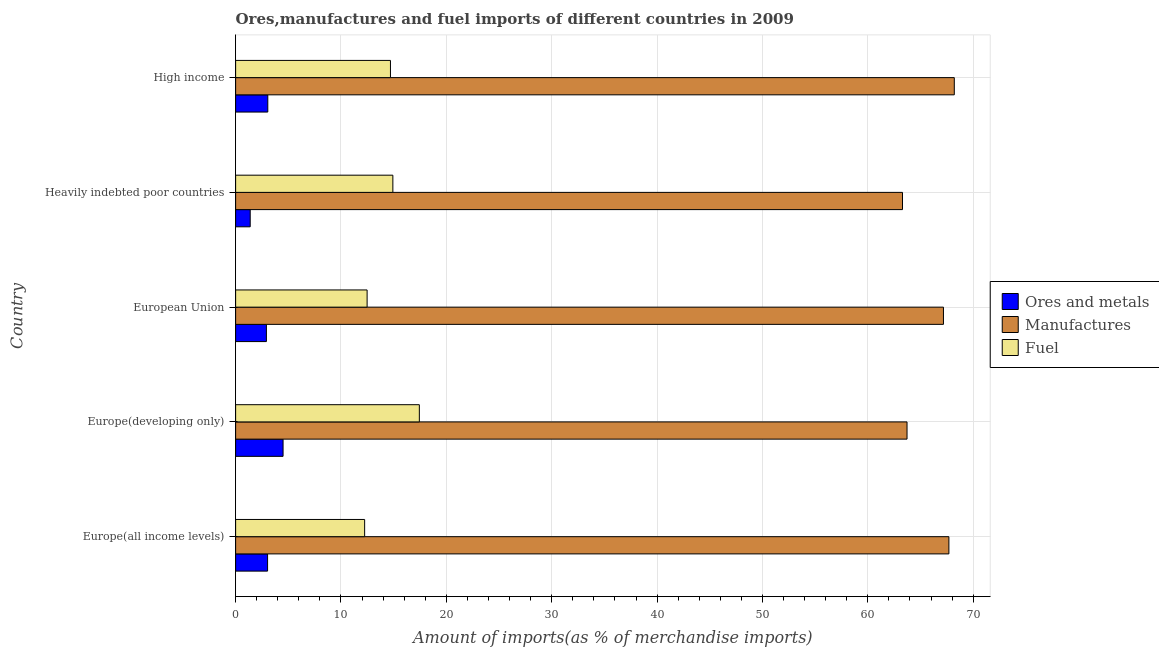How many groups of bars are there?
Your answer should be very brief. 5. Are the number of bars per tick equal to the number of legend labels?
Provide a short and direct response. Yes. How many bars are there on the 4th tick from the bottom?
Offer a very short reply. 3. What is the label of the 4th group of bars from the top?
Provide a short and direct response. Europe(developing only). What is the percentage of fuel imports in Europe(all income levels)?
Make the answer very short. 12.24. Across all countries, what is the maximum percentage of ores and metals imports?
Your answer should be compact. 4.5. Across all countries, what is the minimum percentage of manufactures imports?
Make the answer very short. 63.29. In which country was the percentage of ores and metals imports maximum?
Offer a terse response. Europe(developing only). In which country was the percentage of ores and metals imports minimum?
Your answer should be very brief. Heavily indebted poor countries. What is the total percentage of manufactures imports in the graph?
Make the answer very short. 330.09. What is the difference between the percentage of fuel imports in European Union and that in High income?
Your response must be concise. -2.22. What is the difference between the percentage of ores and metals imports in High income and the percentage of manufactures imports in Europe(all income levels)?
Make the answer very short. -64.64. What is the average percentage of ores and metals imports per country?
Keep it short and to the point. 2.98. What is the difference between the percentage of fuel imports and percentage of manufactures imports in Heavily indebted poor countries?
Provide a succinct answer. -48.37. In how many countries, is the percentage of ores and metals imports greater than 42 %?
Your response must be concise. 0. Is the percentage of fuel imports in Europe(all income levels) less than that in Heavily indebted poor countries?
Your answer should be compact. Yes. Is the difference between the percentage of manufactures imports in Heavily indebted poor countries and High income greater than the difference between the percentage of fuel imports in Heavily indebted poor countries and High income?
Make the answer very short. No. What is the difference between the highest and the second highest percentage of manufactures imports?
Your answer should be very brief. 0.51. What is the difference between the highest and the lowest percentage of ores and metals imports?
Offer a very short reply. 3.12. In how many countries, is the percentage of ores and metals imports greater than the average percentage of ores and metals imports taken over all countries?
Make the answer very short. 3. What does the 3rd bar from the top in Heavily indebted poor countries represents?
Make the answer very short. Ores and metals. What does the 1st bar from the bottom in Europe(all income levels) represents?
Your response must be concise. Ores and metals. How many bars are there?
Your response must be concise. 15. Are all the bars in the graph horizontal?
Offer a terse response. Yes. What is the difference between two consecutive major ticks on the X-axis?
Give a very brief answer. 10. Does the graph contain grids?
Ensure brevity in your answer.  Yes. How many legend labels are there?
Make the answer very short. 3. How are the legend labels stacked?
Offer a very short reply. Vertical. What is the title of the graph?
Your answer should be compact. Ores,manufactures and fuel imports of different countries in 2009. Does "Textiles and clothing" appear as one of the legend labels in the graph?
Your answer should be very brief. No. What is the label or title of the X-axis?
Offer a very short reply. Amount of imports(as % of merchandise imports). What is the label or title of the Y-axis?
Make the answer very short. Country. What is the Amount of imports(as % of merchandise imports) of Ores and metals in Europe(all income levels)?
Your answer should be very brief. 3.03. What is the Amount of imports(as % of merchandise imports) of Manufactures in Europe(all income levels)?
Offer a very short reply. 67.69. What is the Amount of imports(as % of merchandise imports) of Fuel in Europe(all income levels)?
Ensure brevity in your answer.  12.24. What is the Amount of imports(as % of merchandise imports) of Ores and metals in Europe(developing only)?
Offer a very short reply. 4.5. What is the Amount of imports(as % of merchandise imports) of Manufactures in Europe(developing only)?
Offer a terse response. 63.72. What is the Amount of imports(as % of merchandise imports) of Fuel in Europe(developing only)?
Make the answer very short. 17.44. What is the Amount of imports(as % of merchandise imports) in Ores and metals in European Union?
Your answer should be compact. 2.92. What is the Amount of imports(as % of merchandise imports) in Manufactures in European Union?
Ensure brevity in your answer.  67.18. What is the Amount of imports(as % of merchandise imports) in Fuel in European Union?
Give a very brief answer. 12.48. What is the Amount of imports(as % of merchandise imports) of Ores and metals in Heavily indebted poor countries?
Provide a short and direct response. 1.38. What is the Amount of imports(as % of merchandise imports) of Manufactures in Heavily indebted poor countries?
Offer a terse response. 63.29. What is the Amount of imports(as % of merchandise imports) in Fuel in Heavily indebted poor countries?
Provide a short and direct response. 14.92. What is the Amount of imports(as % of merchandise imports) in Ores and metals in High income?
Your answer should be very brief. 3.05. What is the Amount of imports(as % of merchandise imports) of Manufactures in High income?
Ensure brevity in your answer.  68.21. What is the Amount of imports(as % of merchandise imports) of Fuel in High income?
Your answer should be compact. 14.7. Across all countries, what is the maximum Amount of imports(as % of merchandise imports) in Ores and metals?
Your answer should be very brief. 4.5. Across all countries, what is the maximum Amount of imports(as % of merchandise imports) of Manufactures?
Offer a very short reply. 68.21. Across all countries, what is the maximum Amount of imports(as % of merchandise imports) of Fuel?
Offer a very short reply. 17.44. Across all countries, what is the minimum Amount of imports(as % of merchandise imports) in Ores and metals?
Ensure brevity in your answer.  1.38. Across all countries, what is the minimum Amount of imports(as % of merchandise imports) of Manufactures?
Provide a succinct answer. 63.29. Across all countries, what is the minimum Amount of imports(as % of merchandise imports) in Fuel?
Your answer should be very brief. 12.24. What is the total Amount of imports(as % of merchandise imports) of Ores and metals in the graph?
Offer a very short reply. 14.9. What is the total Amount of imports(as % of merchandise imports) in Manufactures in the graph?
Your answer should be compact. 330.09. What is the total Amount of imports(as % of merchandise imports) in Fuel in the graph?
Your response must be concise. 71.78. What is the difference between the Amount of imports(as % of merchandise imports) of Ores and metals in Europe(all income levels) and that in Europe(developing only)?
Keep it short and to the point. -1.47. What is the difference between the Amount of imports(as % of merchandise imports) of Manufactures in Europe(all income levels) and that in Europe(developing only)?
Give a very brief answer. 3.97. What is the difference between the Amount of imports(as % of merchandise imports) of Fuel in Europe(all income levels) and that in Europe(developing only)?
Offer a terse response. -5.19. What is the difference between the Amount of imports(as % of merchandise imports) in Manufactures in Europe(all income levels) and that in European Union?
Keep it short and to the point. 0.52. What is the difference between the Amount of imports(as % of merchandise imports) in Fuel in Europe(all income levels) and that in European Union?
Give a very brief answer. -0.23. What is the difference between the Amount of imports(as % of merchandise imports) in Ores and metals in Europe(all income levels) and that in Heavily indebted poor countries?
Give a very brief answer. 1.65. What is the difference between the Amount of imports(as % of merchandise imports) in Manufactures in Europe(all income levels) and that in Heavily indebted poor countries?
Provide a short and direct response. 4.4. What is the difference between the Amount of imports(as % of merchandise imports) of Fuel in Europe(all income levels) and that in Heavily indebted poor countries?
Offer a very short reply. -2.68. What is the difference between the Amount of imports(as % of merchandise imports) in Ores and metals in Europe(all income levels) and that in High income?
Ensure brevity in your answer.  -0.02. What is the difference between the Amount of imports(as % of merchandise imports) in Manufactures in Europe(all income levels) and that in High income?
Your answer should be very brief. -0.51. What is the difference between the Amount of imports(as % of merchandise imports) in Fuel in Europe(all income levels) and that in High income?
Ensure brevity in your answer.  -2.45. What is the difference between the Amount of imports(as % of merchandise imports) in Ores and metals in Europe(developing only) and that in European Union?
Provide a short and direct response. 1.58. What is the difference between the Amount of imports(as % of merchandise imports) of Manufactures in Europe(developing only) and that in European Union?
Make the answer very short. -3.46. What is the difference between the Amount of imports(as % of merchandise imports) in Fuel in Europe(developing only) and that in European Union?
Make the answer very short. 4.96. What is the difference between the Amount of imports(as % of merchandise imports) of Ores and metals in Europe(developing only) and that in Heavily indebted poor countries?
Your answer should be compact. 3.12. What is the difference between the Amount of imports(as % of merchandise imports) of Manufactures in Europe(developing only) and that in Heavily indebted poor countries?
Provide a succinct answer. 0.43. What is the difference between the Amount of imports(as % of merchandise imports) of Fuel in Europe(developing only) and that in Heavily indebted poor countries?
Keep it short and to the point. 2.51. What is the difference between the Amount of imports(as % of merchandise imports) in Ores and metals in Europe(developing only) and that in High income?
Give a very brief answer. 1.45. What is the difference between the Amount of imports(as % of merchandise imports) in Manufactures in Europe(developing only) and that in High income?
Your answer should be compact. -4.49. What is the difference between the Amount of imports(as % of merchandise imports) in Fuel in Europe(developing only) and that in High income?
Keep it short and to the point. 2.74. What is the difference between the Amount of imports(as % of merchandise imports) in Ores and metals in European Union and that in Heavily indebted poor countries?
Provide a succinct answer. 1.54. What is the difference between the Amount of imports(as % of merchandise imports) of Manufactures in European Union and that in Heavily indebted poor countries?
Make the answer very short. 3.89. What is the difference between the Amount of imports(as % of merchandise imports) in Fuel in European Union and that in Heavily indebted poor countries?
Your answer should be compact. -2.44. What is the difference between the Amount of imports(as % of merchandise imports) of Ores and metals in European Union and that in High income?
Make the answer very short. -0.13. What is the difference between the Amount of imports(as % of merchandise imports) in Manufactures in European Union and that in High income?
Your answer should be very brief. -1.03. What is the difference between the Amount of imports(as % of merchandise imports) in Fuel in European Union and that in High income?
Ensure brevity in your answer.  -2.22. What is the difference between the Amount of imports(as % of merchandise imports) in Ores and metals in Heavily indebted poor countries and that in High income?
Provide a short and direct response. -1.67. What is the difference between the Amount of imports(as % of merchandise imports) of Manufactures in Heavily indebted poor countries and that in High income?
Give a very brief answer. -4.92. What is the difference between the Amount of imports(as % of merchandise imports) of Fuel in Heavily indebted poor countries and that in High income?
Keep it short and to the point. 0.23. What is the difference between the Amount of imports(as % of merchandise imports) of Ores and metals in Europe(all income levels) and the Amount of imports(as % of merchandise imports) of Manufactures in Europe(developing only)?
Your answer should be compact. -60.69. What is the difference between the Amount of imports(as % of merchandise imports) in Ores and metals in Europe(all income levels) and the Amount of imports(as % of merchandise imports) in Fuel in Europe(developing only)?
Your response must be concise. -14.4. What is the difference between the Amount of imports(as % of merchandise imports) of Manufactures in Europe(all income levels) and the Amount of imports(as % of merchandise imports) of Fuel in Europe(developing only)?
Provide a short and direct response. 50.26. What is the difference between the Amount of imports(as % of merchandise imports) of Ores and metals in Europe(all income levels) and the Amount of imports(as % of merchandise imports) of Manufactures in European Union?
Provide a succinct answer. -64.14. What is the difference between the Amount of imports(as % of merchandise imports) of Ores and metals in Europe(all income levels) and the Amount of imports(as % of merchandise imports) of Fuel in European Union?
Offer a terse response. -9.45. What is the difference between the Amount of imports(as % of merchandise imports) of Manufactures in Europe(all income levels) and the Amount of imports(as % of merchandise imports) of Fuel in European Union?
Give a very brief answer. 55.22. What is the difference between the Amount of imports(as % of merchandise imports) in Ores and metals in Europe(all income levels) and the Amount of imports(as % of merchandise imports) in Manufactures in Heavily indebted poor countries?
Your answer should be compact. -60.26. What is the difference between the Amount of imports(as % of merchandise imports) in Ores and metals in Europe(all income levels) and the Amount of imports(as % of merchandise imports) in Fuel in Heavily indebted poor countries?
Give a very brief answer. -11.89. What is the difference between the Amount of imports(as % of merchandise imports) of Manufactures in Europe(all income levels) and the Amount of imports(as % of merchandise imports) of Fuel in Heavily indebted poor countries?
Give a very brief answer. 52.77. What is the difference between the Amount of imports(as % of merchandise imports) in Ores and metals in Europe(all income levels) and the Amount of imports(as % of merchandise imports) in Manufactures in High income?
Offer a very short reply. -65.17. What is the difference between the Amount of imports(as % of merchandise imports) in Ores and metals in Europe(all income levels) and the Amount of imports(as % of merchandise imports) in Fuel in High income?
Provide a short and direct response. -11.66. What is the difference between the Amount of imports(as % of merchandise imports) of Manufactures in Europe(all income levels) and the Amount of imports(as % of merchandise imports) of Fuel in High income?
Your response must be concise. 53. What is the difference between the Amount of imports(as % of merchandise imports) of Ores and metals in Europe(developing only) and the Amount of imports(as % of merchandise imports) of Manufactures in European Union?
Your response must be concise. -62.67. What is the difference between the Amount of imports(as % of merchandise imports) in Ores and metals in Europe(developing only) and the Amount of imports(as % of merchandise imports) in Fuel in European Union?
Keep it short and to the point. -7.98. What is the difference between the Amount of imports(as % of merchandise imports) of Manufactures in Europe(developing only) and the Amount of imports(as % of merchandise imports) of Fuel in European Union?
Make the answer very short. 51.24. What is the difference between the Amount of imports(as % of merchandise imports) of Ores and metals in Europe(developing only) and the Amount of imports(as % of merchandise imports) of Manufactures in Heavily indebted poor countries?
Make the answer very short. -58.79. What is the difference between the Amount of imports(as % of merchandise imports) in Ores and metals in Europe(developing only) and the Amount of imports(as % of merchandise imports) in Fuel in Heavily indebted poor countries?
Give a very brief answer. -10.42. What is the difference between the Amount of imports(as % of merchandise imports) in Manufactures in Europe(developing only) and the Amount of imports(as % of merchandise imports) in Fuel in Heavily indebted poor countries?
Offer a very short reply. 48.8. What is the difference between the Amount of imports(as % of merchandise imports) of Ores and metals in Europe(developing only) and the Amount of imports(as % of merchandise imports) of Manufactures in High income?
Keep it short and to the point. -63.7. What is the difference between the Amount of imports(as % of merchandise imports) of Ores and metals in Europe(developing only) and the Amount of imports(as % of merchandise imports) of Fuel in High income?
Your answer should be very brief. -10.19. What is the difference between the Amount of imports(as % of merchandise imports) of Manufactures in Europe(developing only) and the Amount of imports(as % of merchandise imports) of Fuel in High income?
Keep it short and to the point. 49.03. What is the difference between the Amount of imports(as % of merchandise imports) of Ores and metals in European Union and the Amount of imports(as % of merchandise imports) of Manufactures in Heavily indebted poor countries?
Provide a short and direct response. -60.37. What is the difference between the Amount of imports(as % of merchandise imports) of Ores and metals in European Union and the Amount of imports(as % of merchandise imports) of Fuel in Heavily indebted poor countries?
Give a very brief answer. -12. What is the difference between the Amount of imports(as % of merchandise imports) in Manufactures in European Union and the Amount of imports(as % of merchandise imports) in Fuel in Heavily indebted poor countries?
Provide a succinct answer. 52.25. What is the difference between the Amount of imports(as % of merchandise imports) in Ores and metals in European Union and the Amount of imports(as % of merchandise imports) in Manufactures in High income?
Provide a succinct answer. -65.29. What is the difference between the Amount of imports(as % of merchandise imports) in Ores and metals in European Union and the Amount of imports(as % of merchandise imports) in Fuel in High income?
Make the answer very short. -11.77. What is the difference between the Amount of imports(as % of merchandise imports) in Manufactures in European Union and the Amount of imports(as % of merchandise imports) in Fuel in High income?
Provide a succinct answer. 52.48. What is the difference between the Amount of imports(as % of merchandise imports) in Ores and metals in Heavily indebted poor countries and the Amount of imports(as % of merchandise imports) in Manufactures in High income?
Your response must be concise. -66.82. What is the difference between the Amount of imports(as % of merchandise imports) of Ores and metals in Heavily indebted poor countries and the Amount of imports(as % of merchandise imports) of Fuel in High income?
Offer a terse response. -13.31. What is the difference between the Amount of imports(as % of merchandise imports) in Manufactures in Heavily indebted poor countries and the Amount of imports(as % of merchandise imports) in Fuel in High income?
Your answer should be very brief. 48.6. What is the average Amount of imports(as % of merchandise imports) of Ores and metals per country?
Keep it short and to the point. 2.98. What is the average Amount of imports(as % of merchandise imports) in Manufactures per country?
Provide a short and direct response. 66.02. What is the average Amount of imports(as % of merchandise imports) in Fuel per country?
Make the answer very short. 14.36. What is the difference between the Amount of imports(as % of merchandise imports) of Ores and metals and Amount of imports(as % of merchandise imports) of Manufactures in Europe(all income levels)?
Provide a short and direct response. -64.66. What is the difference between the Amount of imports(as % of merchandise imports) of Ores and metals and Amount of imports(as % of merchandise imports) of Fuel in Europe(all income levels)?
Provide a short and direct response. -9.21. What is the difference between the Amount of imports(as % of merchandise imports) of Manufactures and Amount of imports(as % of merchandise imports) of Fuel in Europe(all income levels)?
Offer a very short reply. 55.45. What is the difference between the Amount of imports(as % of merchandise imports) in Ores and metals and Amount of imports(as % of merchandise imports) in Manufactures in Europe(developing only)?
Keep it short and to the point. -59.22. What is the difference between the Amount of imports(as % of merchandise imports) of Ores and metals and Amount of imports(as % of merchandise imports) of Fuel in Europe(developing only)?
Your answer should be compact. -12.93. What is the difference between the Amount of imports(as % of merchandise imports) of Manufactures and Amount of imports(as % of merchandise imports) of Fuel in Europe(developing only)?
Offer a terse response. 46.29. What is the difference between the Amount of imports(as % of merchandise imports) in Ores and metals and Amount of imports(as % of merchandise imports) in Manufactures in European Union?
Offer a terse response. -64.26. What is the difference between the Amount of imports(as % of merchandise imports) of Ores and metals and Amount of imports(as % of merchandise imports) of Fuel in European Union?
Ensure brevity in your answer.  -9.56. What is the difference between the Amount of imports(as % of merchandise imports) of Manufactures and Amount of imports(as % of merchandise imports) of Fuel in European Union?
Give a very brief answer. 54.7. What is the difference between the Amount of imports(as % of merchandise imports) of Ores and metals and Amount of imports(as % of merchandise imports) of Manufactures in Heavily indebted poor countries?
Make the answer very short. -61.91. What is the difference between the Amount of imports(as % of merchandise imports) in Ores and metals and Amount of imports(as % of merchandise imports) in Fuel in Heavily indebted poor countries?
Give a very brief answer. -13.54. What is the difference between the Amount of imports(as % of merchandise imports) in Manufactures and Amount of imports(as % of merchandise imports) in Fuel in Heavily indebted poor countries?
Make the answer very short. 48.37. What is the difference between the Amount of imports(as % of merchandise imports) in Ores and metals and Amount of imports(as % of merchandise imports) in Manufactures in High income?
Keep it short and to the point. -65.15. What is the difference between the Amount of imports(as % of merchandise imports) in Ores and metals and Amount of imports(as % of merchandise imports) in Fuel in High income?
Offer a terse response. -11.64. What is the difference between the Amount of imports(as % of merchandise imports) in Manufactures and Amount of imports(as % of merchandise imports) in Fuel in High income?
Ensure brevity in your answer.  53.51. What is the ratio of the Amount of imports(as % of merchandise imports) of Ores and metals in Europe(all income levels) to that in Europe(developing only)?
Give a very brief answer. 0.67. What is the ratio of the Amount of imports(as % of merchandise imports) of Manufactures in Europe(all income levels) to that in Europe(developing only)?
Ensure brevity in your answer.  1.06. What is the ratio of the Amount of imports(as % of merchandise imports) of Fuel in Europe(all income levels) to that in Europe(developing only)?
Offer a very short reply. 0.7. What is the ratio of the Amount of imports(as % of merchandise imports) of Ores and metals in Europe(all income levels) to that in European Union?
Your response must be concise. 1.04. What is the ratio of the Amount of imports(as % of merchandise imports) in Manufactures in Europe(all income levels) to that in European Union?
Provide a succinct answer. 1.01. What is the ratio of the Amount of imports(as % of merchandise imports) in Fuel in Europe(all income levels) to that in European Union?
Give a very brief answer. 0.98. What is the ratio of the Amount of imports(as % of merchandise imports) of Ores and metals in Europe(all income levels) to that in Heavily indebted poor countries?
Ensure brevity in your answer.  2.19. What is the ratio of the Amount of imports(as % of merchandise imports) of Manufactures in Europe(all income levels) to that in Heavily indebted poor countries?
Your response must be concise. 1.07. What is the ratio of the Amount of imports(as % of merchandise imports) in Fuel in Europe(all income levels) to that in Heavily indebted poor countries?
Offer a very short reply. 0.82. What is the ratio of the Amount of imports(as % of merchandise imports) in Ores and metals in Europe(all income levels) to that in High income?
Ensure brevity in your answer.  0.99. What is the ratio of the Amount of imports(as % of merchandise imports) in Fuel in Europe(all income levels) to that in High income?
Offer a very short reply. 0.83. What is the ratio of the Amount of imports(as % of merchandise imports) of Ores and metals in Europe(developing only) to that in European Union?
Provide a succinct answer. 1.54. What is the ratio of the Amount of imports(as % of merchandise imports) in Manufactures in Europe(developing only) to that in European Union?
Your answer should be compact. 0.95. What is the ratio of the Amount of imports(as % of merchandise imports) of Fuel in Europe(developing only) to that in European Union?
Give a very brief answer. 1.4. What is the ratio of the Amount of imports(as % of merchandise imports) of Ores and metals in Europe(developing only) to that in Heavily indebted poor countries?
Your answer should be compact. 3.25. What is the ratio of the Amount of imports(as % of merchandise imports) in Manufactures in Europe(developing only) to that in Heavily indebted poor countries?
Your answer should be compact. 1.01. What is the ratio of the Amount of imports(as % of merchandise imports) of Fuel in Europe(developing only) to that in Heavily indebted poor countries?
Keep it short and to the point. 1.17. What is the ratio of the Amount of imports(as % of merchandise imports) of Ores and metals in Europe(developing only) to that in High income?
Make the answer very short. 1.47. What is the ratio of the Amount of imports(as % of merchandise imports) in Manufactures in Europe(developing only) to that in High income?
Offer a terse response. 0.93. What is the ratio of the Amount of imports(as % of merchandise imports) of Fuel in Europe(developing only) to that in High income?
Keep it short and to the point. 1.19. What is the ratio of the Amount of imports(as % of merchandise imports) in Ores and metals in European Union to that in Heavily indebted poor countries?
Provide a succinct answer. 2.11. What is the ratio of the Amount of imports(as % of merchandise imports) of Manufactures in European Union to that in Heavily indebted poor countries?
Ensure brevity in your answer.  1.06. What is the ratio of the Amount of imports(as % of merchandise imports) in Fuel in European Union to that in Heavily indebted poor countries?
Provide a succinct answer. 0.84. What is the ratio of the Amount of imports(as % of merchandise imports) in Ores and metals in European Union to that in High income?
Your answer should be compact. 0.96. What is the ratio of the Amount of imports(as % of merchandise imports) in Manufactures in European Union to that in High income?
Keep it short and to the point. 0.98. What is the ratio of the Amount of imports(as % of merchandise imports) in Fuel in European Union to that in High income?
Your response must be concise. 0.85. What is the ratio of the Amount of imports(as % of merchandise imports) of Ores and metals in Heavily indebted poor countries to that in High income?
Provide a succinct answer. 0.45. What is the ratio of the Amount of imports(as % of merchandise imports) of Manufactures in Heavily indebted poor countries to that in High income?
Ensure brevity in your answer.  0.93. What is the ratio of the Amount of imports(as % of merchandise imports) of Fuel in Heavily indebted poor countries to that in High income?
Keep it short and to the point. 1.02. What is the difference between the highest and the second highest Amount of imports(as % of merchandise imports) in Ores and metals?
Offer a very short reply. 1.45. What is the difference between the highest and the second highest Amount of imports(as % of merchandise imports) of Manufactures?
Provide a succinct answer. 0.51. What is the difference between the highest and the second highest Amount of imports(as % of merchandise imports) in Fuel?
Offer a very short reply. 2.51. What is the difference between the highest and the lowest Amount of imports(as % of merchandise imports) of Ores and metals?
Ensure brevity in your answer.  3.12. What is the difference between the highest and the lowest Amount of imports(as % of merchandise imports) in Manufactures?
Provide a succinct answer. 4.92. What is the difference between the highest and the lowest Amount of imports(as % of merchandise imports) of Fuel?
Your response must be concise. 5.19. 